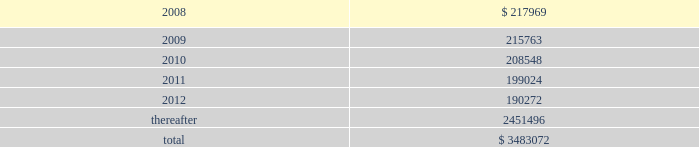American tower corporation and subsidiaries notes to consolidated financial statements 2014 ( continued ) as of december 31 , 2006 , the company held a total of ten interest rate swap agreements to manage exposure to variable rate interest obligations under its amt opco and spectrasite credit facilities and four forward starting interest rate swap agreements to manage exposure to variability in cash flows relating to forecasted interest payments in connection with the securitization which the company designated as cash flow hedges .
The eight american tower swaps had an aggregate notional amount of $ 450.0 million and fixed rates ranging between 4.63% ( 4.63 % ) and 4.88% ( 4.88 % ) and the two spectrasite swaps have an aggregate notional amount of $ 100.0 million and a fixed rate of 4.95% ( 4.95 % ) .
The four forward starting interest rate swap agreements had an aggregate notional amount of $ 900.0 million , fixed rates ranging between 4.73% ( 4.73 % ) and 5.10% ( 5.10 % ) .
As of december 31 , 2006 , the company also held three interest rate swap instruments and one interest rate cap instrument that were acquired in the spectrasite , inc .
Merger in august 2005 and were not designated as cash flow hedges .
The three interest rate swaps , which had a fair value of $ 6.7 million at the date of acquisition , have an aggregate notional amount of $ 300.0 million , a fixed rate of 3.88% ( 3.88 % ) .
The interest rate cap had a notional amount of $ 175.0 million , a fixed rate of 7.0% ( 7.0 % ) , and expired in february 2006 .
As of december 31 , 2006 , other comprehensive income includes unrealized gains on short term available-for-sale securities of $ 10.4 million and unrealized gains related to the interest rate swap agreements in the table above of $ 5.7 million , net of tax .
During the year ended december 31 , 2006 , the company recorded a net unrealized gain of approximately $ 6.5 million ( net of a tax provision of approximately $ 3.5 million ) in other comprehensive loss for the change in fair value of interest rate swaps designated as cash flow hedges and reclassified $ 0.7 million ( net of an income tax benefit of $ 0.2 million ) into results of operations during the year ended december 31 , 2006 .
Commitments and contingencies lease obligations 2014the company leases certain land , office and tower space under operating leases that expire over various terms .
Many of the leases contain renewal options with specified increases in lease payments upon exercise of the renewal option .
Escalation clauses present in operating leases , excluding those tied to cpi or other inflation-based indices , are recognized on a straight-line basis over the non-cancelable term of the lease .
( see note 1. ) future minimum rental payments under non-cancelable operating leases include payments for certain renewal periods at the company 2019s option because failure to renew could result in a loss of the applicable tower site and related revenues from tenant leases , thereby making it reasonably assured that the company will renew the lease .
Such payments in effect at december 31 , 2007 are as follows ( in thousands ) : year ending december 31 .
Aggregate rent expense ( including the effect of straight-line rent expense ) under operating leases for the years ended december 31 , 2007 , 2006 and 2005 approximated $ 246.4 million , $ 237.0 million and $ 168.7 million , respectively. .
As of december 312007 what was the percentage of future minimum rental payments under non-cancelable operating leases in 2010? 
Computations: (208548 / 3483072)
Answer: 0.05987. 